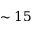Convert formula to latex. <formula><loc_0><loc_0><loc_500><loc_500>\sim 1 5</formula> 